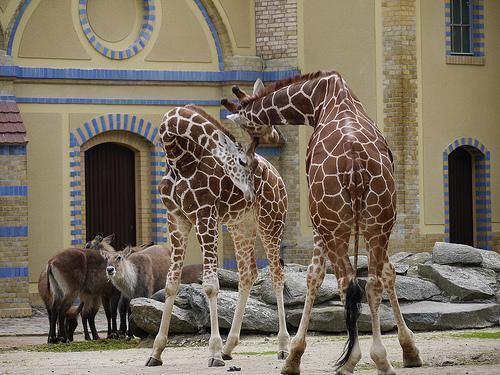How many giraffe are there?
Give a very brief answer. 2. 